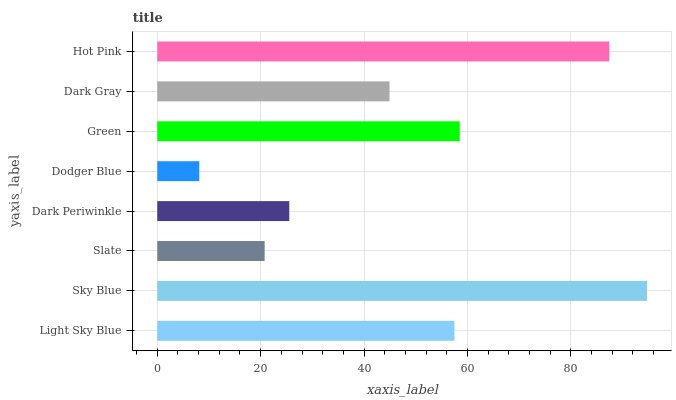Is Dodger Blue the minimum?
Answer yes or no. Yes. Is Sky Blue the maximum?
Answer yes or no. Yes. Is Slate the minimum?
Answer yes or no. No. Is Slate the maximum?
Answer yes or no. No. Is Sky Blue greater than Slate?
Answer yes or no. Yes. Is Slate less than Sky Blue?
Answer yes or no. Yes. Is Slate greater than Sky Blue?
Answer yes or no. No. Is Sky Blue less than Slate?
Answer yes or no. No. Is Light Sky Blue the high median?
Answer yes or no. Yes. Is Dark Gray the low median?
Answer yes or no. Yes. Is Dodger Blue the high median?
Answer yes or no. No. Is Hot Pink the low median?
Answer yes or no. No. 